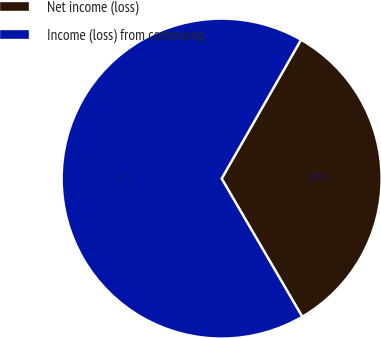Convert chart to OTSL. <chart><loc_0><loc_0><loc_500><loc_500><pie_chart><fcel>Net income (loss)<fcel>Income (loss) from continuing<nl><fcel>33.33%<fcel>66.67%<nl></chart> 